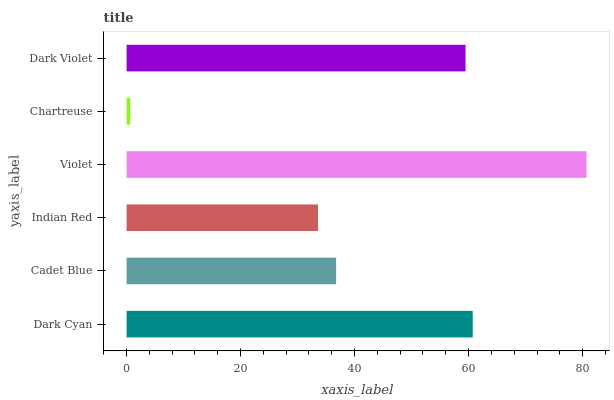Is Chartreuse the minimum?
Answer yes or no. Yes. Is Violet the maximum?
Answer yes or no. Yes. Is Cadet Blue the minimum?
Answer yes or no. No. Is Cadet Blue the maximum?
Answer yes or no. No. Is Dark Cyan greater than Cadet Blue?
Answer yes or no. Yes. Is Cadet Blue less than Dark Cyan?
Answer yes or no. Yes. Is Cadet Blue greater than Dark Cyan?
Answer yes or no. No. Is Dark Cyan less than Cadet Blue?
Answer yes or no. No. Is Dark Violet the high median?
Answer yes or no. Yes. Is Cadet Blue the low median?
Answer yes or no. Yes. Is Dark Cyan the high median?
Answer yes or no. No. Is Indian Red the low median?
Answer yes or no. No. 